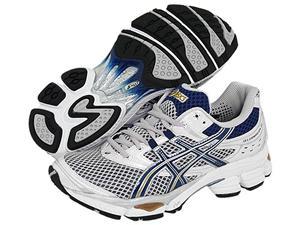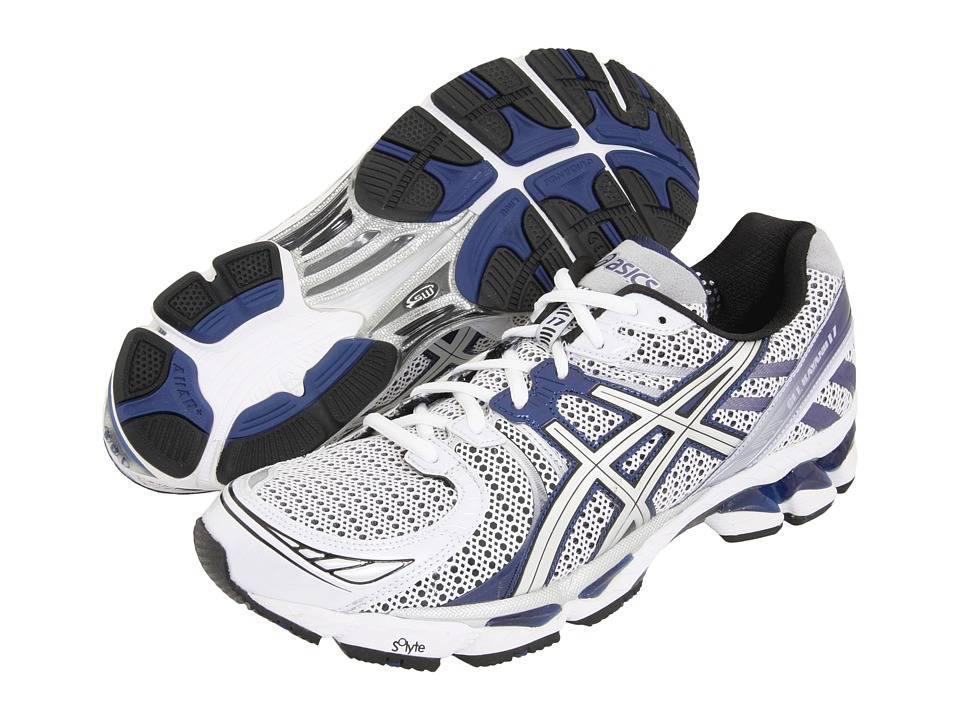The first image is the image on the left, the second image is the image on the right. Evaluate the accuracy of this statement regarding the images: "One image shows a pair of sneakers and the other image features a single right-facing sneaker, and all sneakers feature some shade of blue somewhere.". Is it true? Answer yes or no. No. The first image is the image on the left, the second image is the image on the right. Considering the images on both sides, is "The right image contains exactly one shoe." valid? Answer yes or no. No. 